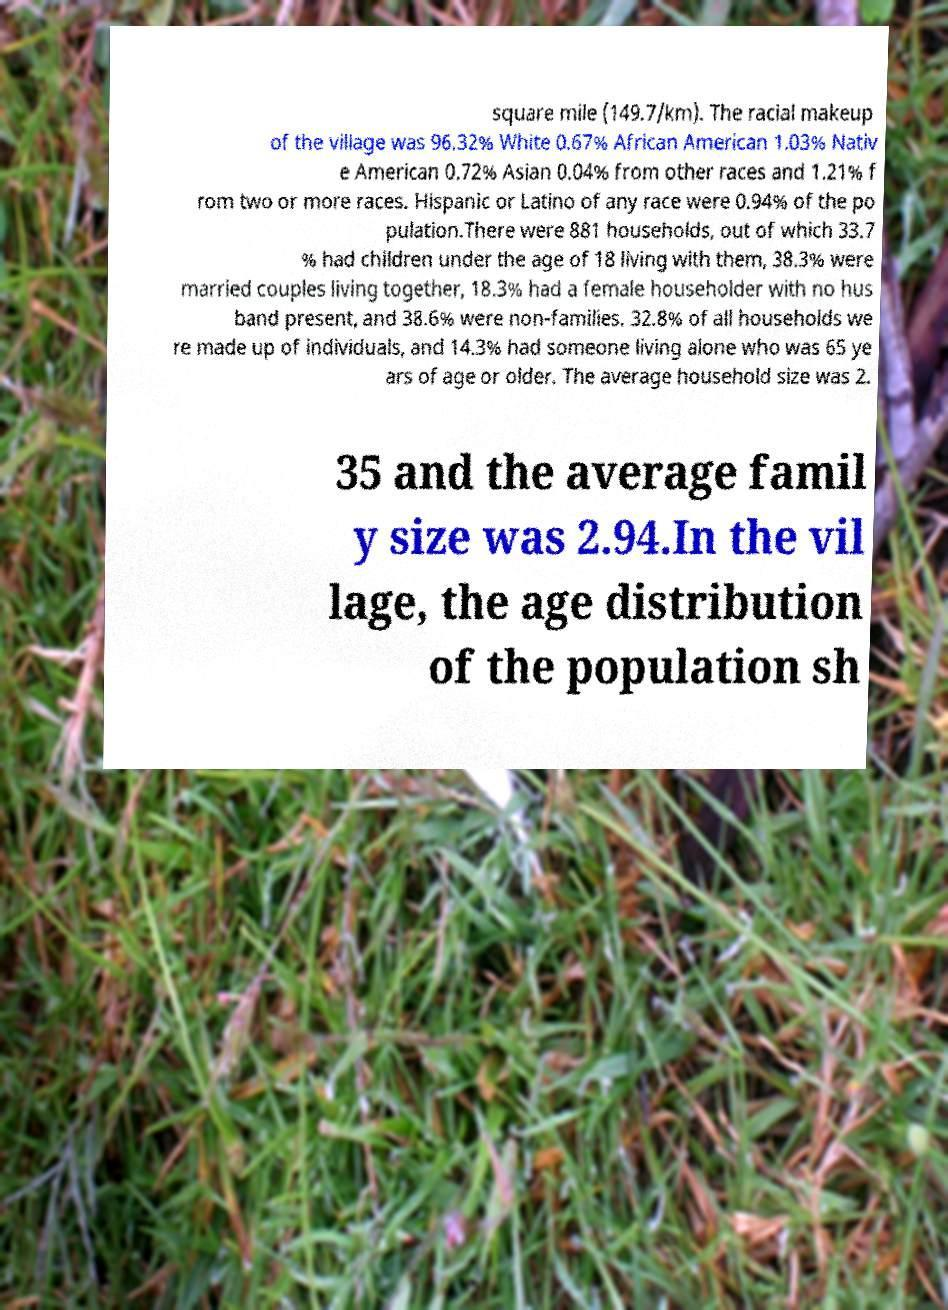I need the written content from this picture converted into text. Can you do that? square mile (149.7/km). The racial makeup of the village was 96.32% White 0.67% African American 1.03% Nativ e American 0.72% Asian 0.04% from other races and 1.21% f rom two or more races. Hispanic or Latino of any race were 0.94% of the po pulation.There were 881 households, out of which 33.7 % had children under the age of 18 living with them, 38.3% were married couples living together, 18.3% had a female householder with no hus band present, and 38.6% were non-families. 32.8% of all households we re made up of individuals, and 14.3% had someone living alone who was 65 ye ars of age or older. The average household size was 2. 35 and the average famil y size was 2.94.In the vil lage, the age distribution of the population sh 